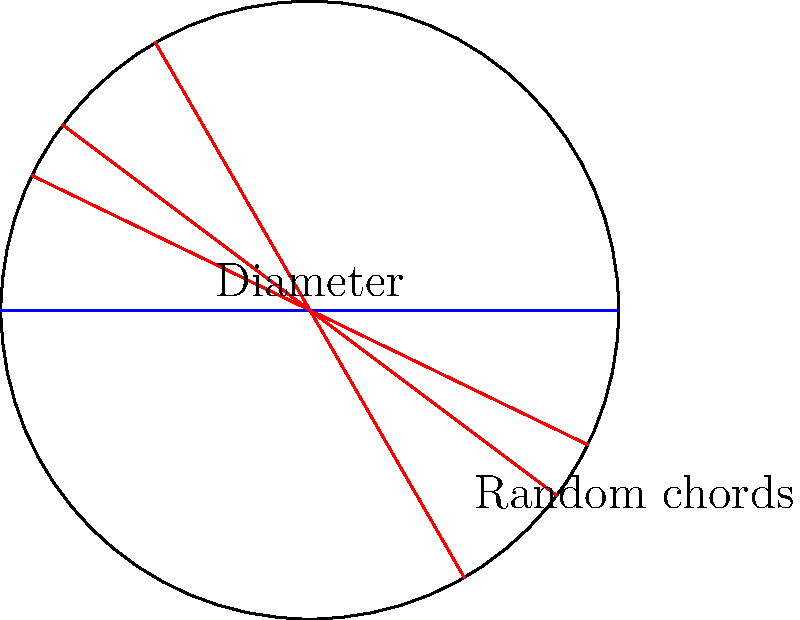In a statistical analysis of circle geometry, 1000 chords are randomly drawn in a circle with diameter 10 units. If the probability of a randomly drawn chord being longer than the radius of the circle is $\frac{1}{\sqrt{3}}$, what is the expected number of chords longer than the radius? Round your answer to the nearest integer. Let's approach this step-by-step:

1) First, we need to understand what the probability $\frac{1}{\sqrt{3}}$ means:
   It's the probability that a randomly drawn chord is longer than the radius.

2) We can interpret this as: out of all possible chords, a fraction of $\frac{1}{\sqrt{3}}$ are longer than the radius.

3) Now, we're drawing 1000 chords randomly. We can treat each draw as an independent event.

4) The expected number of chords longer than the radius can be calculated by multiplying the total number of chords by the probability:

   $$ E(\text{chords longer than radius}) = 1000 \cdot \frac{1}{\sqrt{3}} $$

5) Let's calculate this:
   $$ 1000 \cdot \frac{1}{\sqrt{3}} \approx 1000 \cdot 0.5774 \approx 577.4 $$

6) Rounding to the nearest integer, we get 577.

This result aligns with the Law of Large Numbers in statistics, which states that as the sample size increases, the sample mean approaches the expected value.
Answer: 577 